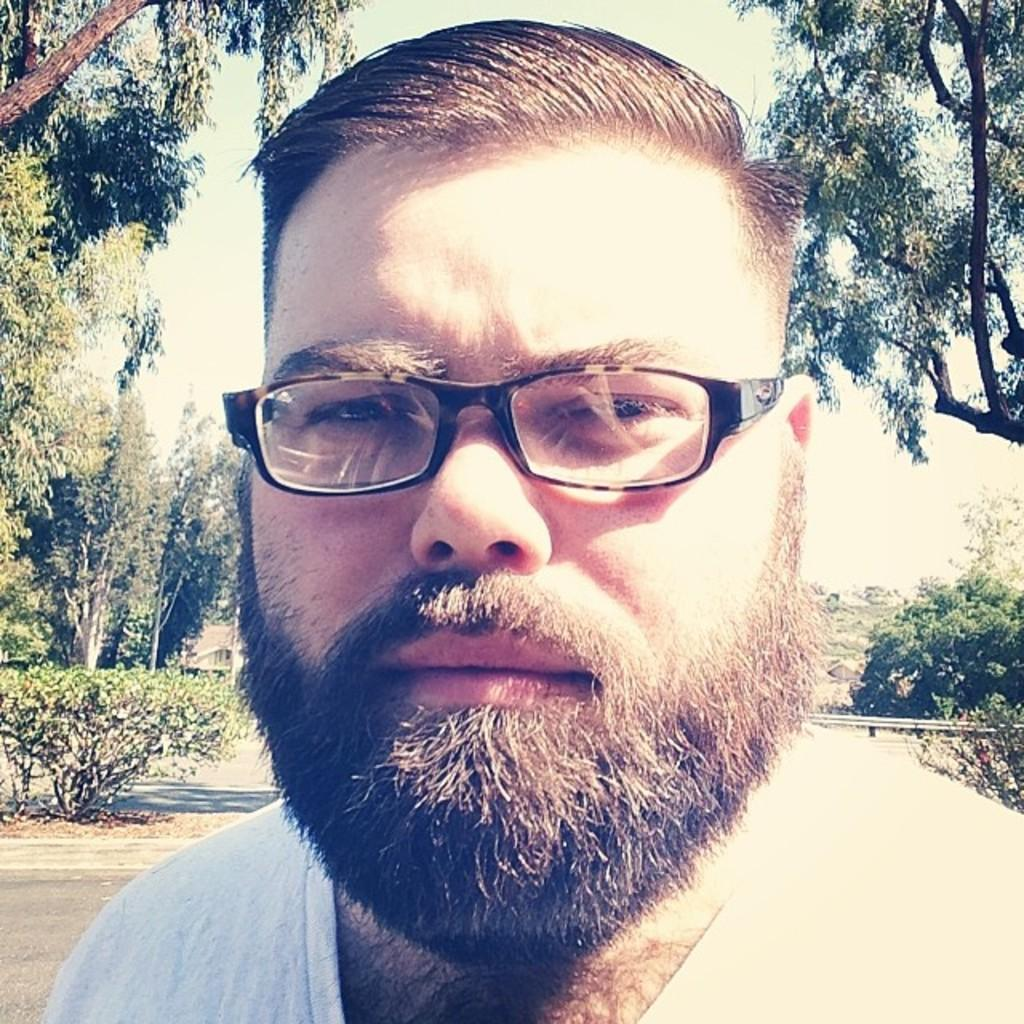Who is present in the image? There is a man in the image. What is the man wearing on his upper body? The man is wearing a white T-shirt. What accessory is the man wearing on his face? The man is wearing spectacles. What type of vegetation can be seen in the image? There are plants and trees in the image. What can be seen in the background of the image? The sky is visible in the background of the image. What does the minister believe about the head in the image? There is no minister or head present in the image; it features a man wearing spectacles and a white T-shirt, surrounded by plants, trees, and the sky. 